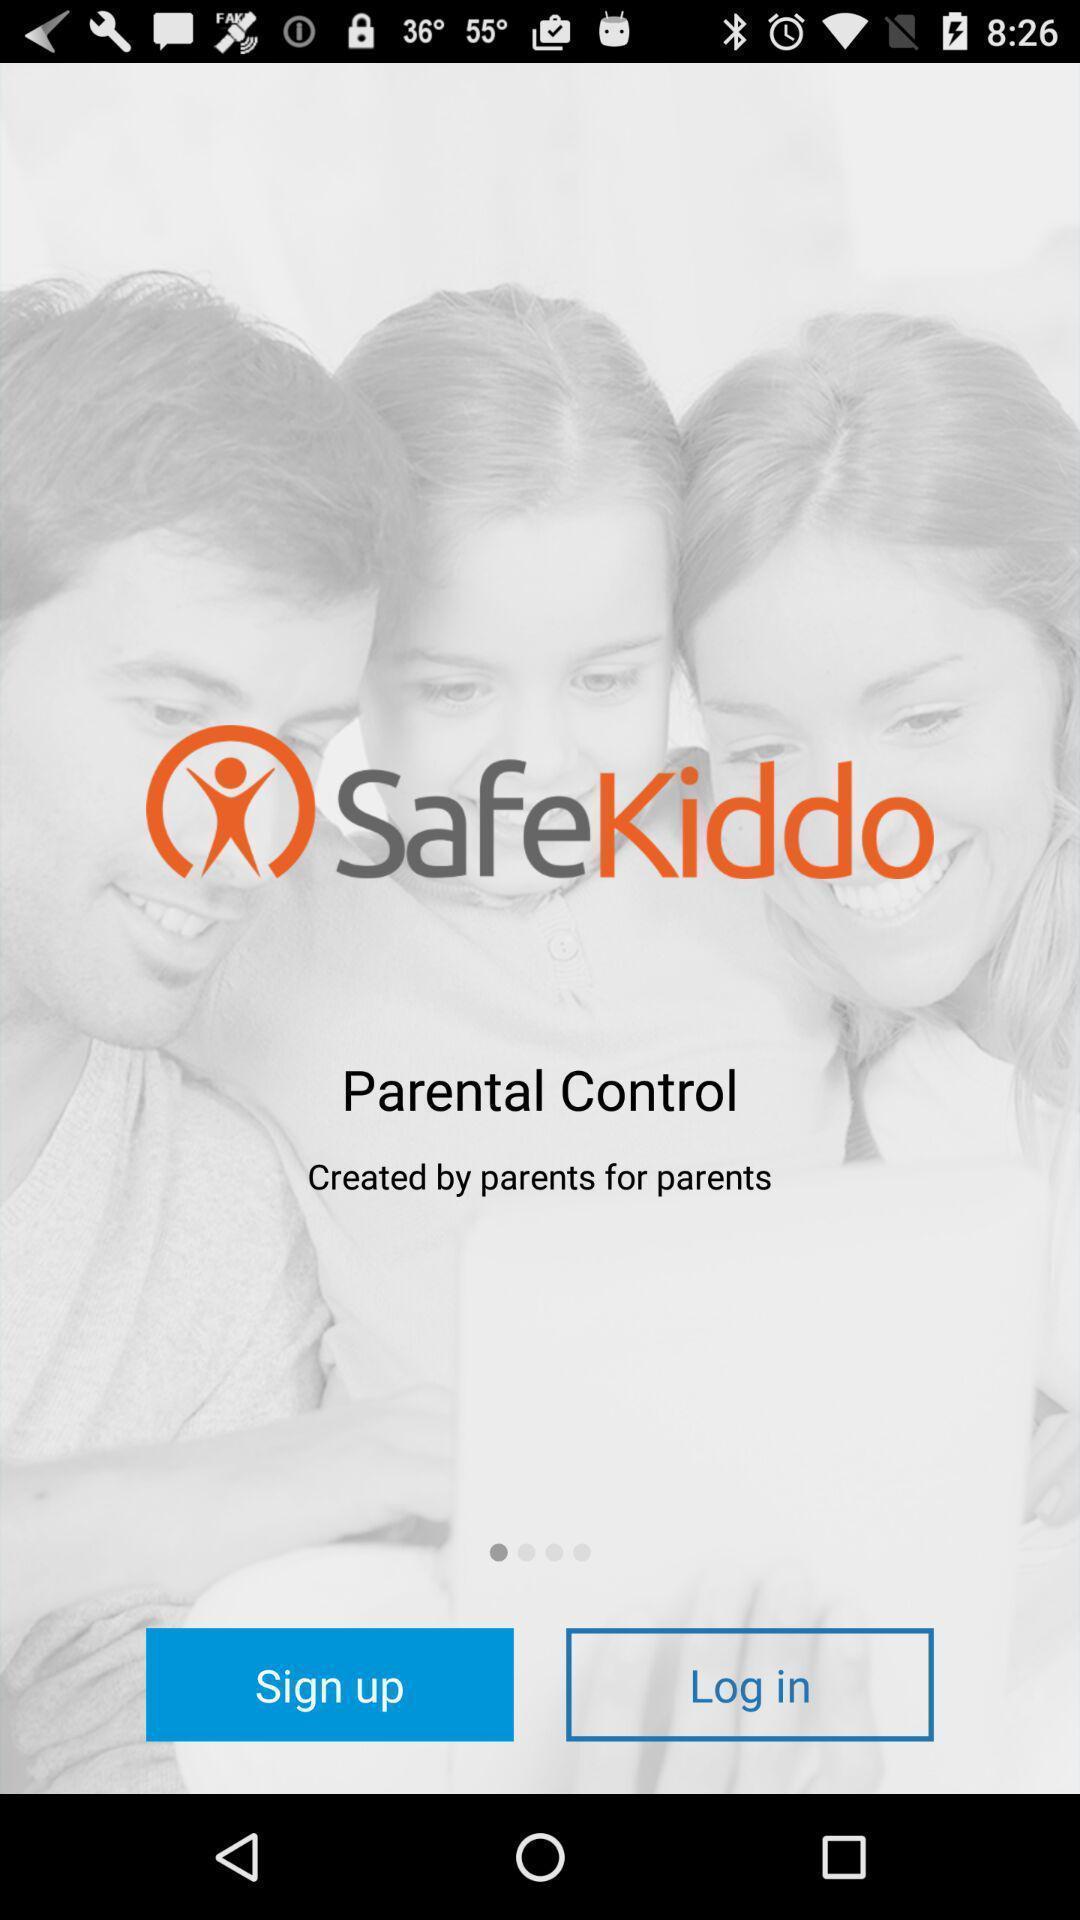What is the overall content of this screenshot? Welcome page of the app. 